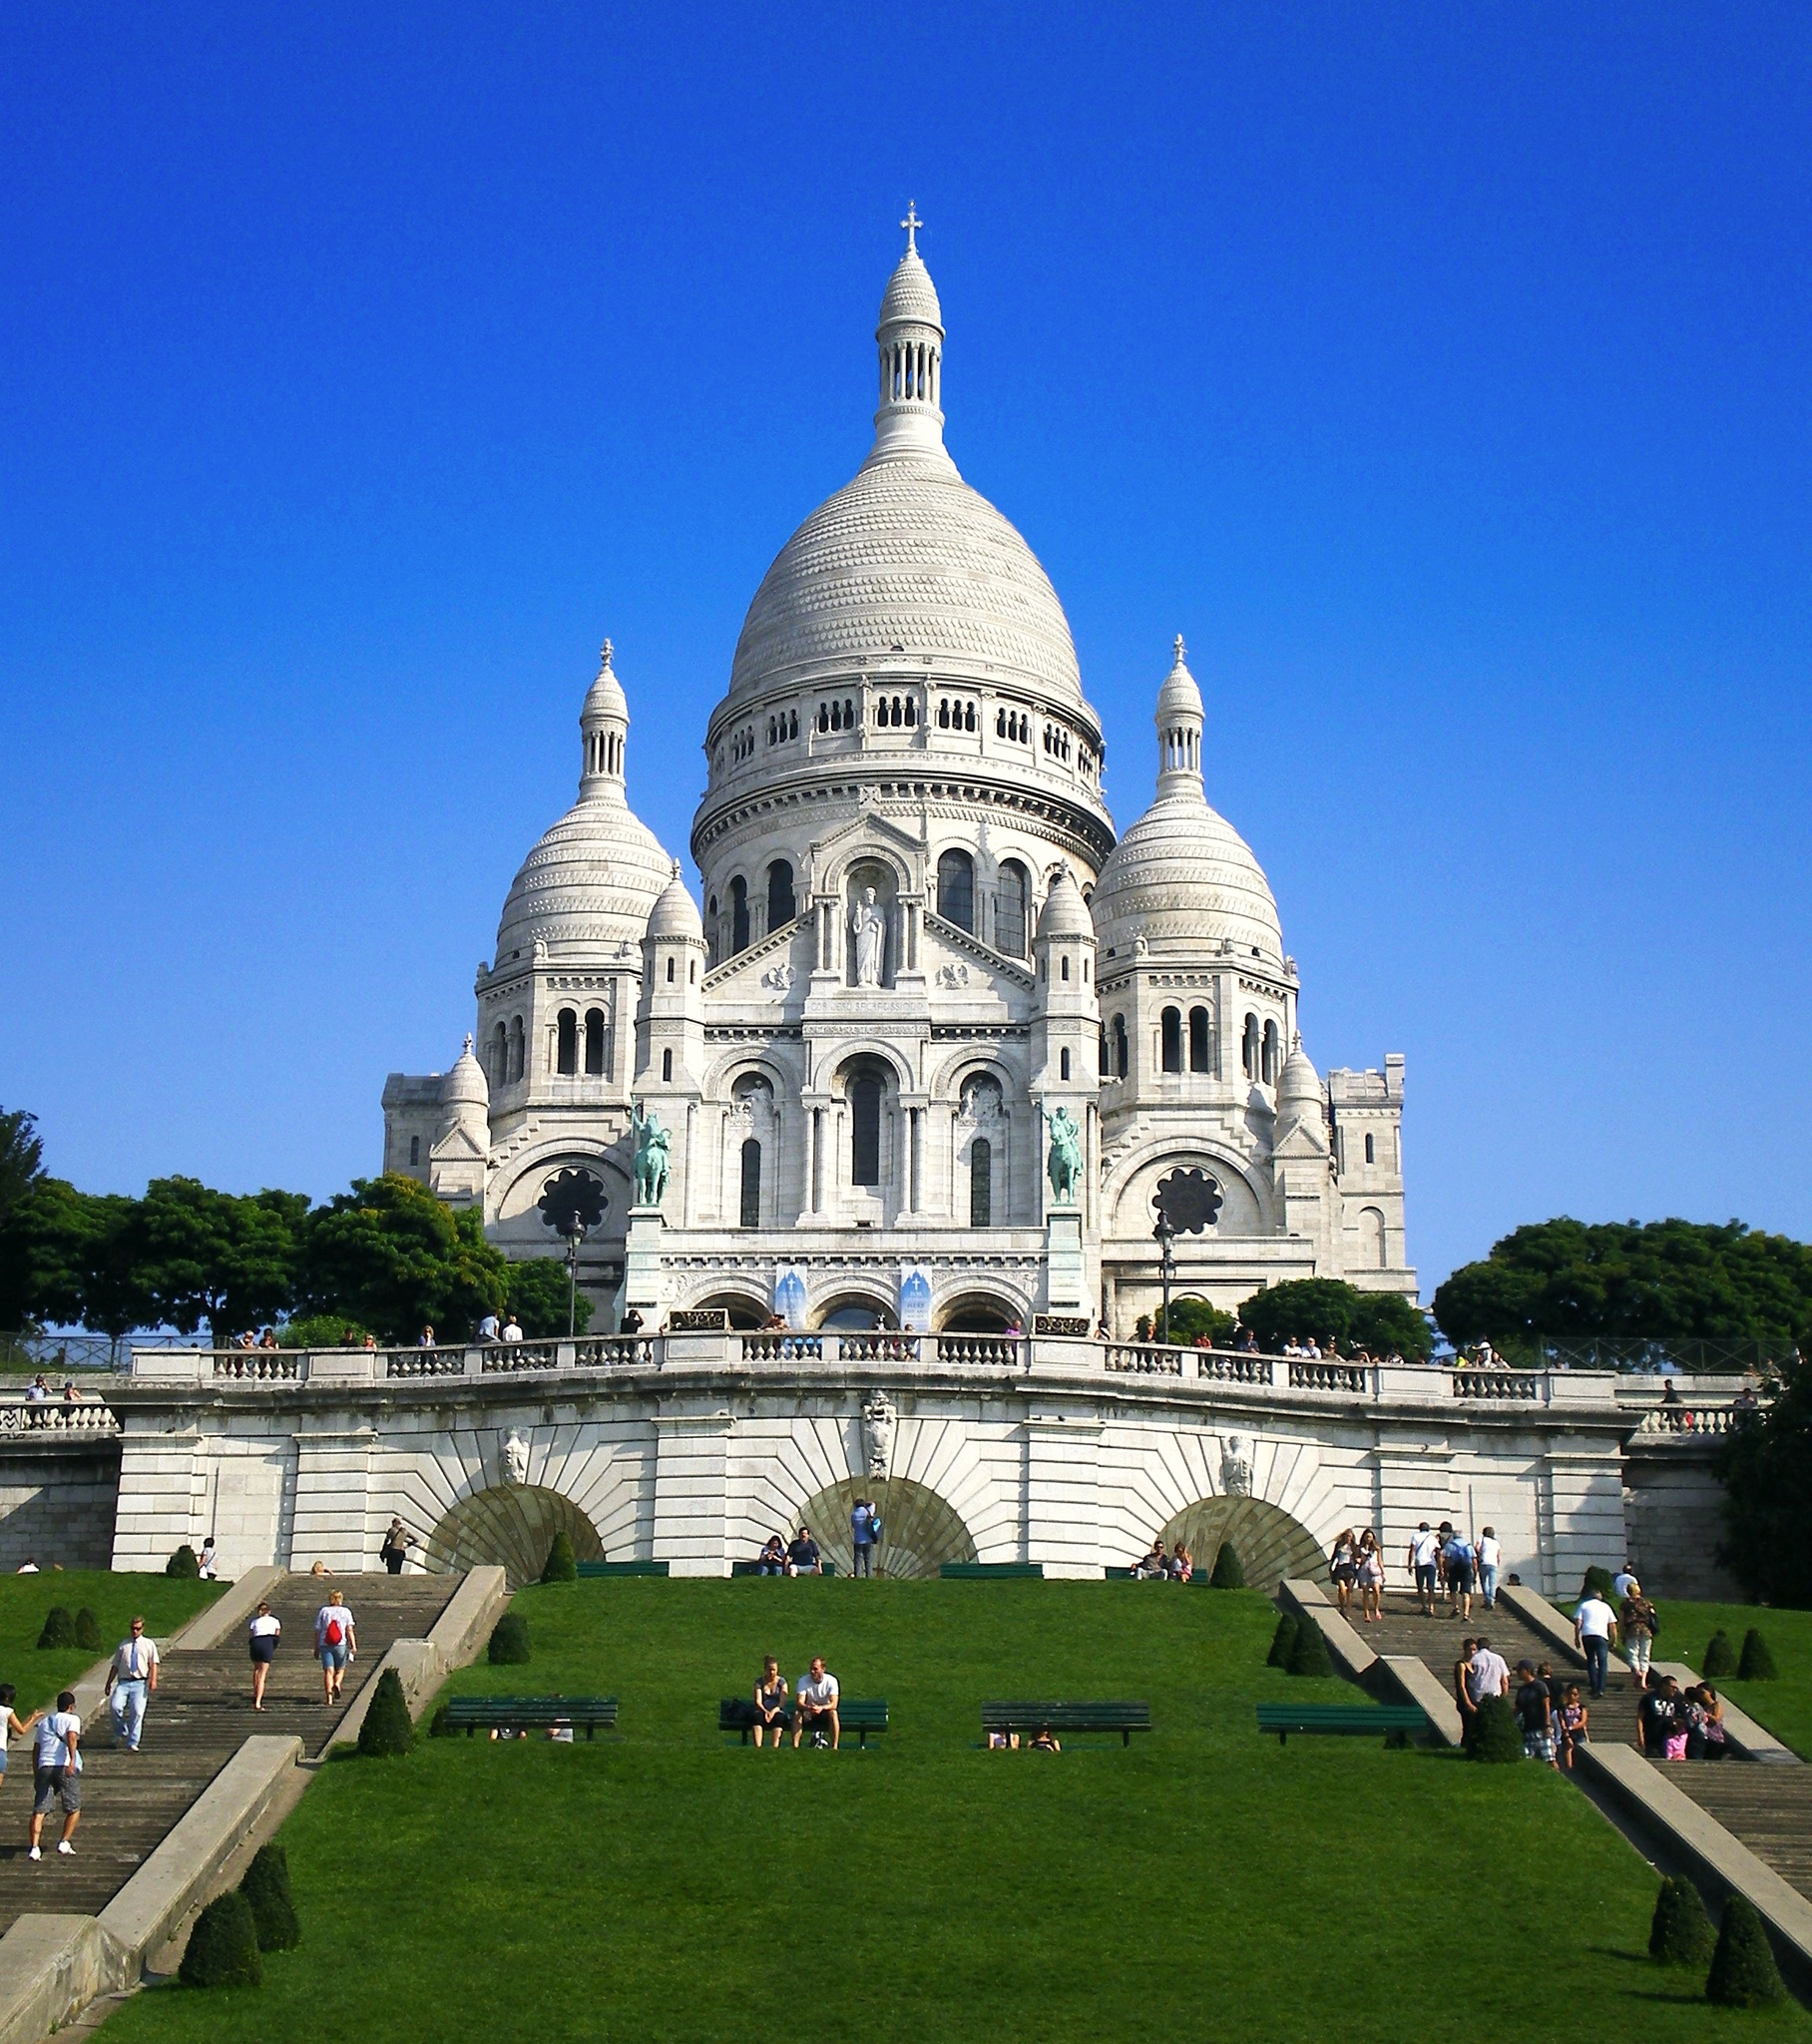Could you tell me more about the architecture of the Sacr�� Coeur? Certainly! The architecture of the Sacr�� Coeur is mainly Romanesque-Byzantine, which is somewhat unique in Paris. The basilica's white stone is constantly exuding calcite, ensuring that it remains brilliantly white even with weathering and pollution. Key features include its four domes, including the central dome which is one of the highest points in Paris, and its bell tower, which houses one of the world's heaviest bells. Are there any unique interior features? Yes, the interior of the Sacr�� Coeur is just as majestic, with one of its most remarkable features being the mosaic in the apse, one of the largest in the world, depicting Christ with outstretched arms. The use of gold and blue in the mosaics creates a celestial atmosphere inside, and the stained glass windows add vibrant hues to the natural light that filters through. 